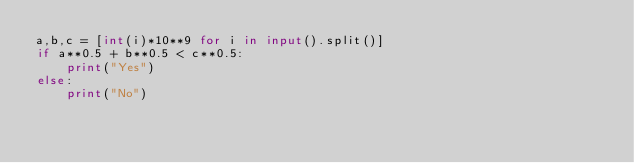Convert code to text. <code><loc_0><loc_0><loc_500><loc_500><_Python_>a,b,c = [int(i)*10**9 for i in input().split()]
if a**0.5 + b**0.5 < c**0.5:
    print("Yes")
else:
    print("No")</code> 